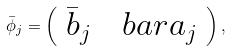<formula> <loc_0><loc_0><loc_500><loc_500>\bar { \phi } _ { j } = \left ( \begin{array} { c } \bar { b } _ { j } \ \ \ b a r { a } _ { j } \end{array} \right ) ,</formula> 